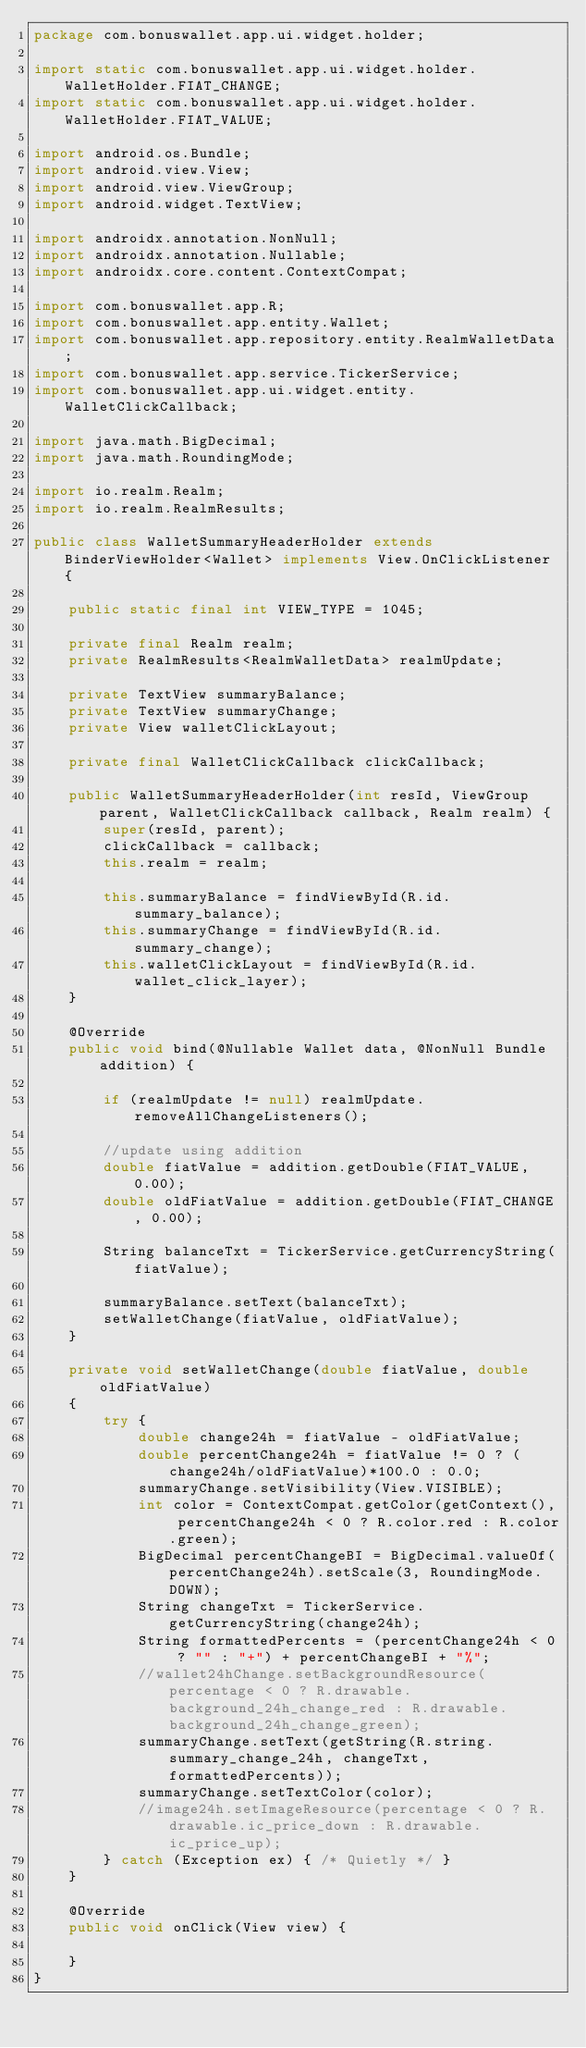Convert code to text. <code><loc_0><loc_0><loc_500><loc_500><_Java_>package com.bonuswallet.app.ui.widget.holder;

import static com.bonuswallet.app.ui.widget.holder.WalletHolder.FIAT_CHANGE;
import static com.bonuswallet.app.ui.widget.holder.WalletHolder.FIAT_VALUE;

import android.os.Bundle;
import android.view.View;
import android.view.ViewGroup;
import android.widget.TextView;

import androidx.annotation.NonNull;
import androidx.annotation.Nullable;
import androidx.core.content.ContextCompat;

import com.bonuswallet.app.R;
import com.bonuswallet.app.entity.Wallet;
import com.bonuswallet.app.repository.entity.RealmWalletData;
import com.bonuswallet.app.service.TickerService;
import com.bonuswallet.app.ui.widget.entity.WalletClickCallback;

import java.math.BigDecimal;
import java.math.RoundingMode;

import io.realm.Realm;
import io.realm.RealmResults;

public class WalletSummaryHeaderHolder extends BinderViewHolder<Wallet> implements View.OnClickListener {

    public static final int VIEW_TYPE = 1045;

    private final Realm realm;
    private RealmResults<RealmWalletData> realmUpdate;

    private TextView summaryBalance;
    private TextView summaryChange;
    private View walletClickLayout;

    private final WalletClickCallback clickCallback;

    public WalletSummaryHeaderHolder(int resId, ViewGroup parent, WalletClickCallback callback, Realm realm) {
        super(resId, parent);
        clickCallback = callback;
        this.realm = realm;

        this.summaryBalance = findViewById(R.id.summary_balance);
        this.summaryChange = findViewById(R.id.summary_change);
        this.walletClickLayout = findViewById(R.id.wallet_click_layer);
    }

    @Override
    public void bind(@Nullable Wallet data, @NonNull Bundle addition) {

        if (realmUpdate != null) realmUpdate.removeAllChangeListeners();

        //update using addition
        double fiatValue = addition.getDouble(FIAT_VALUE, 0.00);
        double oldFiatValue = addition.getDouble(FIAT_CHANGE, 0.00);

        String balanceTxt = TickerService.getCurrencyString(fiatValue);

        summaryBalance.setText(balanceTxt);
        setWalletChange(fiatValue, oldFiatValue);
    }

    private void setWalletChange(double fiatValue, double oldFiatValue)
    {
        try {
            double change24h = fiatValue - oldFiatValue;
            double percentChange24h = fiatValue != 0 ? (change24h/oldFiatValue)*100.0 : 0.0;
            summaryChange.setVisibility(View.VISIBLE);
            int color = ContextCompat.getColor(getContext(), percentChange24h < 0 ? R.color.red : R.color.green);
            BigDecimal percentChangeBI = BigDecimal.valueOf(percentChange24h).setScale(3, RoundingMode.DOWN);
            String changeTxt = TickerService.getCurrencyString(change24h);
            String formattedPercents = (percentChange24h < 0 ? "" : "+") + percentChangeBI + "%";
            //wallet24hChange.setBackgroundResource(percentage < 0 ? R.drawable.background_24h_change_red : R.drawable.background_24h_change_green);
            summaryChange.setText(getString(R.string.summary_change_24h, changeTxt, formattedPercents));
            summaryChange.setTextColor(color);
            //image24h.setImageResource(percentage < 0 ? R.drawable.ic_price_down : R.drawable.ic_price_up);
        } catch (Exception ex) { /* Quietly */ }
    }

    @Override
    public void onClick(View view) {

    }
}
</code> 